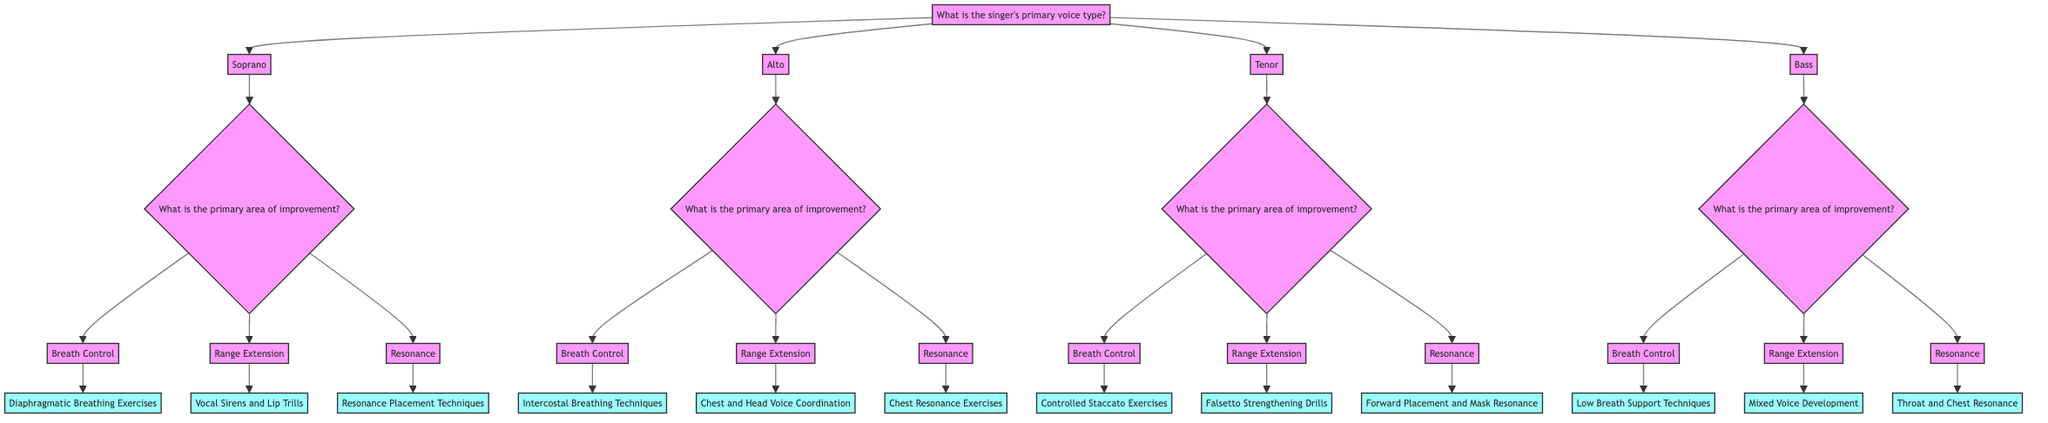What is the singer's primary voice type? The starting node asks for the singer's primary voice type, from which we can choose options such as Soprano, Alto, Tenor, or Bass.
Answer: Soprano, Alto, Tenor, or Bass What is the primary area of improvement for Soprano? Following the Soprano node, the next question asks for the primary area of improvement, which could be Breath Control, Range Extension, or Resonance.
Answer: Breath Control, Range Extension, or Resonance How many strategies are provided for Bass? In the Bass section, there are three areas of improvement mentioned: Breath Control, Range Extension, and Resonance. Each area has one unique strategy, so the total number of strategies is three.
Answer: 3 Which strategy is associated with Range Extension for Tenor? By following the Tenor node to the Range Extension area, we see that the strategy listed is "Falsetto Strengthening Drills."
Answer: Falsetto Strengthening Drills What is the relationship between Soprano and Breath Control? The Soprano node leads to a question about the primary area of improvement, which includes Breath Control as one of the options. Hence, Breath Control is directly related to Soprano as a possible area of improvement.
Answer: Direct relationship, option What is the primary area of improvement for Alto if the focus is on resonance? In the Alto section, the area of improvement under resonance leads to the strategy "Chest Resonance Exercises," indicating we are focusing specifically on resonance improvement for the Alto voice type.
Answer: Chest Resonance Exercises List the strategies under Breath Control for all voice types. To determine the strategies under Breath Control, we traverse each voice type; for Soprano: "Diaphragmatic Breathing Exercises," for Alto: "Intercostal Breathing Techniques," for Tenor: "Controlled Staccato Exercises," and for Bass: "Low Breath Support Techniques."
Answer: Diaphragmatic Breathing Exercises, Intercostal Breathing Techniques, Controlled Staccato Exercises, Low Breath Support Techniques Which strategy improves resonance for Bass? The Bass section under Resonance specifies "Throat and Chest Resonance," which is the strategy that focuses on improving resonance for Bass singers.
Answer: Throat and Chest Resonance How many options are available for primary areas of improvement for each voice type? Each voice type has three primary areas of improvement under which the strategies are organized: Breath Control, Range Extension, and Resonance. Thus, there are three options for each voice type.
Answer: 3 What strategy should a Soprano focus on to enhance resonance? Exploring the Soprano node and going to the Resonance area shows that the strategy is "Resonance Placement Techniques," which is aimed at enhancing resonance for Soprano singers.
Answer: Resonance Placement Techniques 